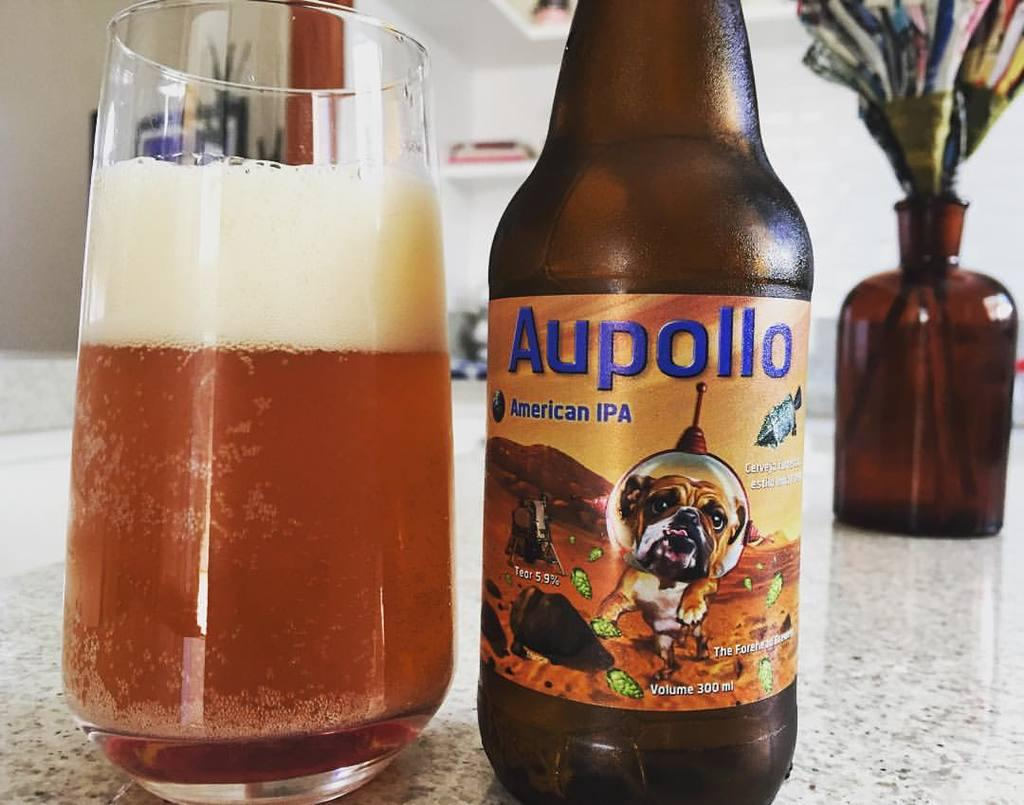<image>
Give a short and clear explanation of the subsequent image. A bottle of Aupollo IPA is poured into a glass. 